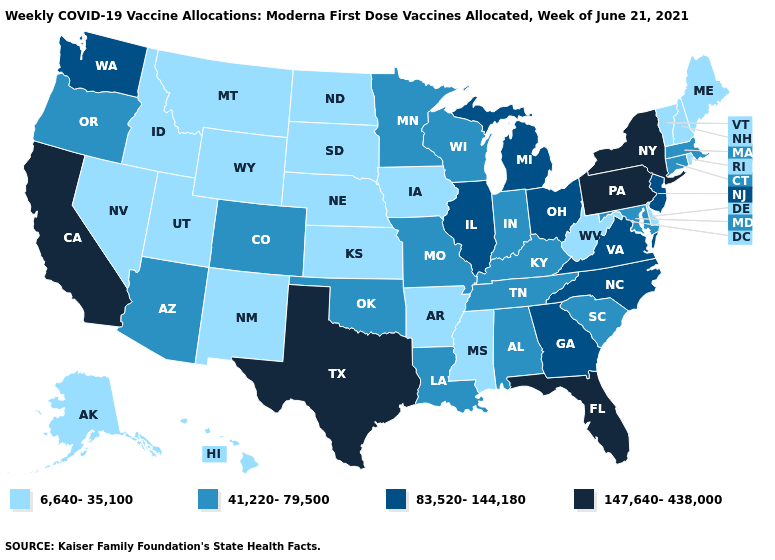Does Utah have the lowest value in the USA?
Keep it brief. Yes. Among the states that border Nebraska , does Missouri have the lowest value?
Short answer required. No. What is the value of Tennessee?
Give a very brief answer. 41,220-79,500. Name the states that have a value in the range 6,640-35,100?
Write a very short answer. Alaska, Arkansas, Delaware, Hawaii, Idaho, Iowa, Kansas, Maine, Mississippi, Montana, Nebraska, Nevada, New Hampshire, New Mexico, North Dakota, Rhode Island, South Dakota, Utah, Vermont, West Virginia, Wyoming. Does the first symbol in the legend represent the smallest category?
Short answer required. Yes. Name the states that have a value in the range 6,640-35,100?
Be succinct. Alaska, Arkansas, Delaware, Hawaii, Idaho, Iowa, Kansas, Maine, Mississippi, Montana, Nebraska, Nevada, New Hampshire, New Mexico, North Dakota, Rhode Island, South Dakota, Utah, Vermont, West Virginia, Wyoming. How many symbols are there in the legend?
Give a very brief answer. 4. What is the highest value in the USA?
Give a very brief answer. 147,640-438,000. What is the lowest value in the South?
Give a very brief answer. 6,640-35,100. What is the lowest value in states that border Vermont?
Short answer required. 6,640-35,100. Name the states that have a value in the range 6,640-35,100?
Keep it brief. Alaska, Arkansas, Delaware, Hawaii, Idaho, Iowa, Kansas, Maine, Mississippi, Montana, Nebraska, Nevada, New Hampshire, New Mexico, North Dakota, Rhode Island, South Dakota, Utah, Vermont, West Virginia, Wyoming. Which states have the lowest value in the USA?
Answer briefly. Alaska, Arkansas, Delaware, Hawaii, Idaho, Iowa, Kansas, Maine, Mississippi, Montana, Nebraska, Nevada, New Hampshire, New Mexico, North Dakota, Rhode Island, South Dakota, Utah, Vermont, West Virginia, Wyoming. Does Arizona have a higher value than Michigan?
Quick response, please. No. Does Wisconsin have the lowest value in the MidWest?
Give a very brief answer. No. 